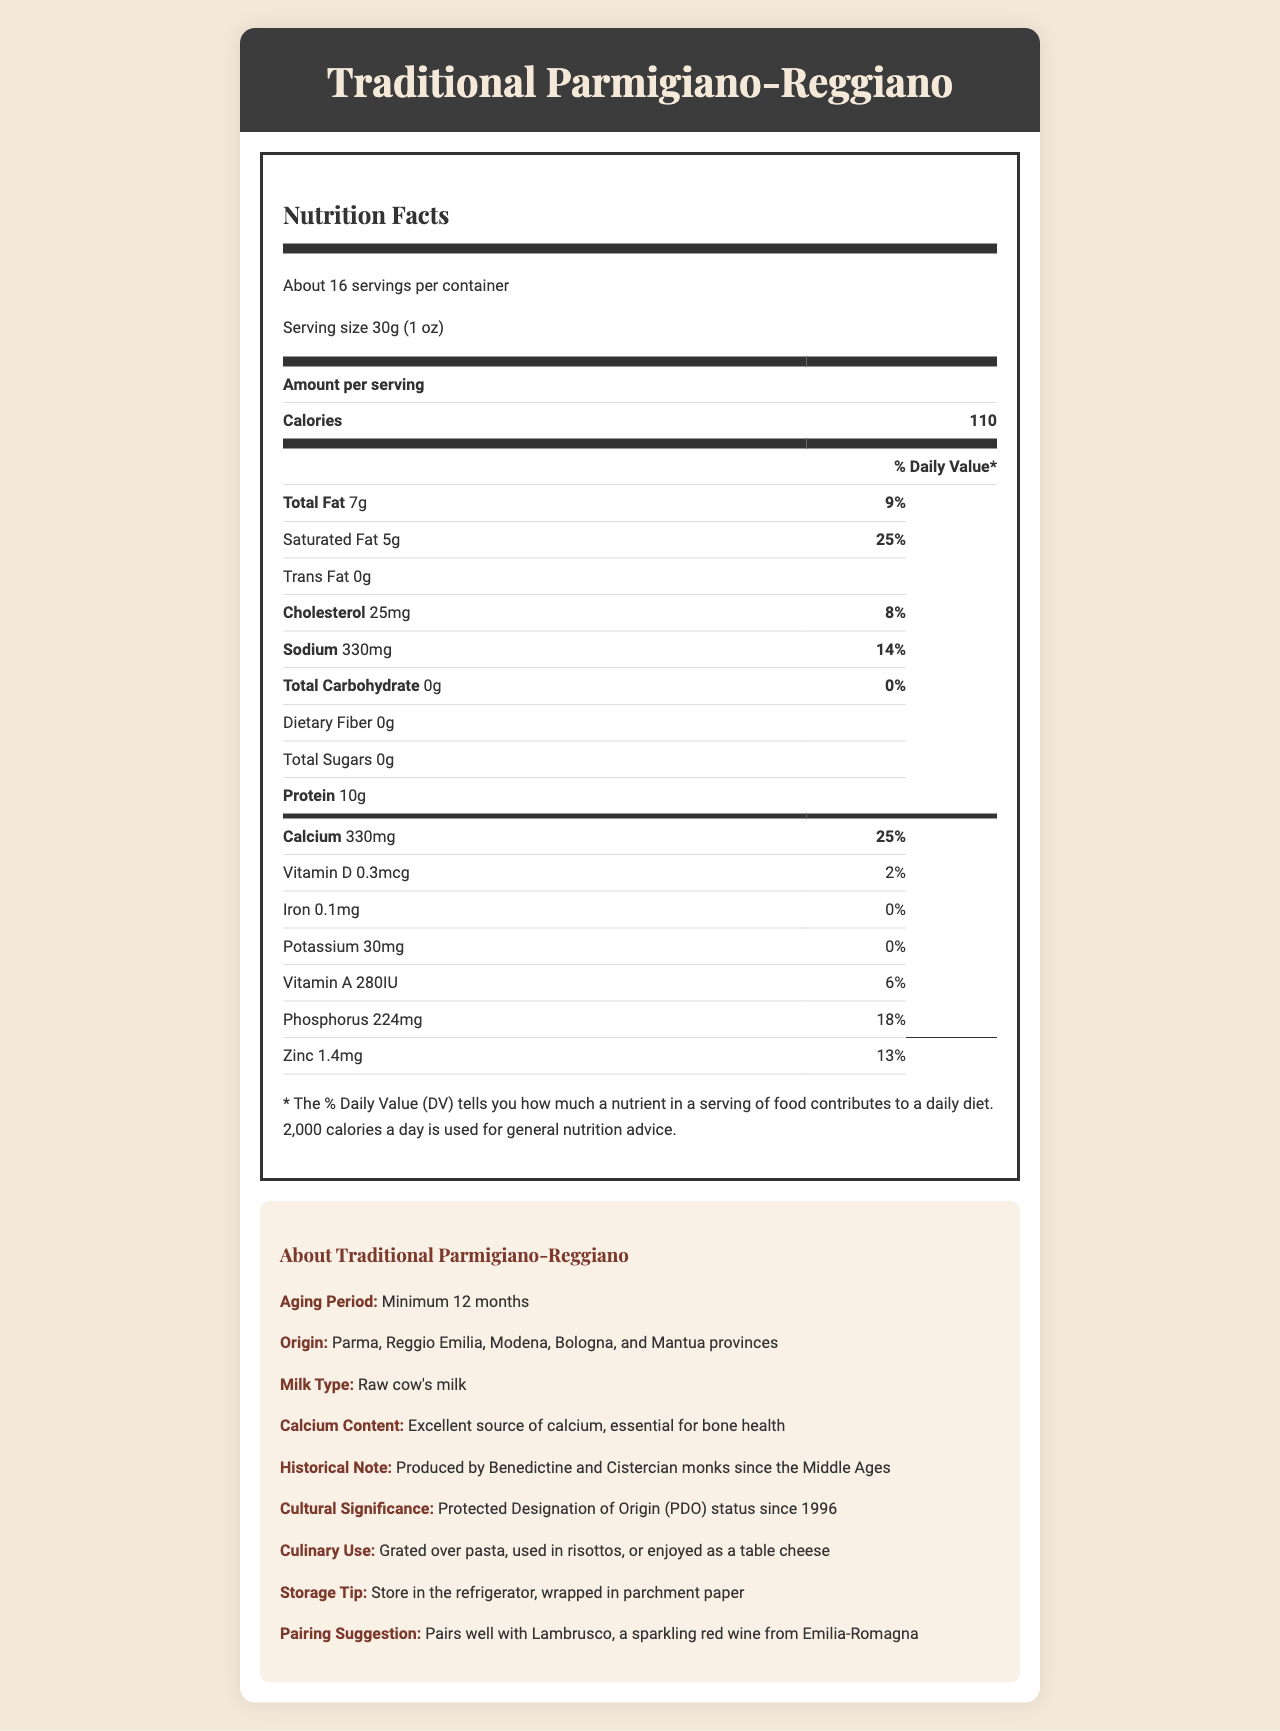What is the serving size of Traditional Parmigiano-Reggiano? The document states that the serving size is 30g (1 oz).
Answer: 30g (1 oz) How much calcium is in one serving? The document states that there is 330mg of calcium in one serving.
Answer: 330mg What is the daily value percentage for calcium in one serving? The document shows that the daily value percentage for calcium in one serving is 25%.
Answer: 25% How much protein does Traditional Parmigiano-Reggiano contain per serving? According to the nutrition label, one serving contains 10g of protein.
Answer: 10g What percentage of the daily value does the sodium content represent? The nutrition label states that the sodium content represents 14% of the daily value.
Answer: 14% Which of the following nutrients is found in the highest daily value percentage per serving? A. Saturated Fat B. Sodium C. Calcium D. Vitamin D The daily value for calcium is 25%, which is the highest compared to Saturated Fat (25%), Sodium (14%), and Vitamin D (2%).
Answer: C. Calcium Which vitamin has the least daily value percentage in one serving? A. Vitamin D B. Vitamin A C. Iron D. Potassium Vitamin D has the least daily value percentage at 2%.
Answer: A. Vitamin D Is Traditional Parmigiano-Reggiano a good source of dietary fiber? The document indicates that it contains 0g of dietary fiber, making it not a good source.
Answer: No Summarize the main nutritional benefits of Traditional Parmigiano-Reggiano cheese. The summary highlights the key nutrients and their benefits, such as high protein and calcium content, as well as the absence of sugars and dietary fiber.
Answer: Traditional Parmigiano-Reggiano cheese provides high protein content (10g) and is an excellent source of calcium (330mg, 25% DV). It also offers notable amounts of vitamin A, phosphorus, and zinc, while being low in carbohydrates and containing no sugars or dietary fiber. How long is the aging period for Traditional Parmigiano-Reggiano? The document states that the aging period is a minimum of 12 months.
Answer: Minimum 12 months Who produced Traditional Parmigiano-Reggiano since the Middle Ages? The historical note in the additional information specifies that the cheese has been produced by Benedictine and Cistercian monks since the Middle Ages.
Answer: Benedictine and Cistercian monks What is the serving size in ounces? The document lists the serving size as 30g (1 oz), so the serving size in ounces is 1 oz.
Answer: 1 oz What wine pairs well with Traditional Parmigiano-Reggiano? The additional information section suggests pairing the cheese with Lambrusco.
Answer: Lambrusco, a sparkling red wine from Emilia-Romagna Does Traditional Parmigiano-Reggiano contain any trans fat? The nutrition label indicates that it contains 0g of trans fat.
Answer: No Where is Traditional Parmigiano-Reggiano produced? A. Tuscany B. Emilia-Romagna C. Piedmont The document specifies that it is produced in the Parma, Reggio Emilia, Modena, Bologna, and Mantua provinces, which are part of the Emilia-Romagna region.
Answer: B. Emilia-Romagna What is the daily value percentage of vitamin A per serving? The nutrition label states that one serving provides 6% of the daily value for vitamin A.
Answer: 6% What is the origin of the milk used in Traditional Parmigiano-Reggiano? The additional information specifies that the cheese is made from raw cow's milk.
Answer: Raw cow's milk How should Traditional Parmigiano-Reggiano be stored? The document advises storing the cheese in the refrigerator, wrapped in parchment paper.
Answer: In the refrigerator, wrapped in parchment paper What other uses are there for Traditional Parmigiano-Reggiano besides being grated over pasta? The document mentions that it can be used in risottos or enjoyed as a table cheese.
Answer: Used in risottos or enjoyed as a table cheese Calculate the total amount of calcium in an entire container of Traditional Parmigiano-Reggiano. If there are about 16 servings per container and each serving contains 330mg of calcium, then the total amount of calcium in the entire container is 330mg x 16 servings = 5280mg.
Answer: 5280mg What is the total number of calories per container? Each serving contains 110 calories, and there are about 16 servings per container. So, the total is 110 calories x 16 servings = 1760 calories.
Answer: 1760 calories What is the percentage of the daily value of iron provided in one serving? The nutrition label shows that one serving provides 0% of the daily value for iron.
Answer: 0% Describe the nutritional content of Traditional Parmigiano-Reggiano in terms of key benefits and ingredients. The detailed explanation consolidates the key benefits and ingredients by highlighting the nutrient content, cultural significance, and culinary uses, providing a comprehensive overview.
Answer: Traditional Parmigiano-Reggiano cheese is rich in protein (10g) and an excellent source of calcium (330mg, 25% DV). It is also a good source of vitamin A, phosphorus, and zinc, and it contains low amounts of sodium and no sugars, dietary fiber, or trans fat. The cheese, made from raw cow's milk and aged for at least 12 months, is highly valued since the Middle Ages and holds cultural significance with PDO status. It pairs well with sparkling red wines and is mainly used over pasta, in risottos, or as a table cheese. 